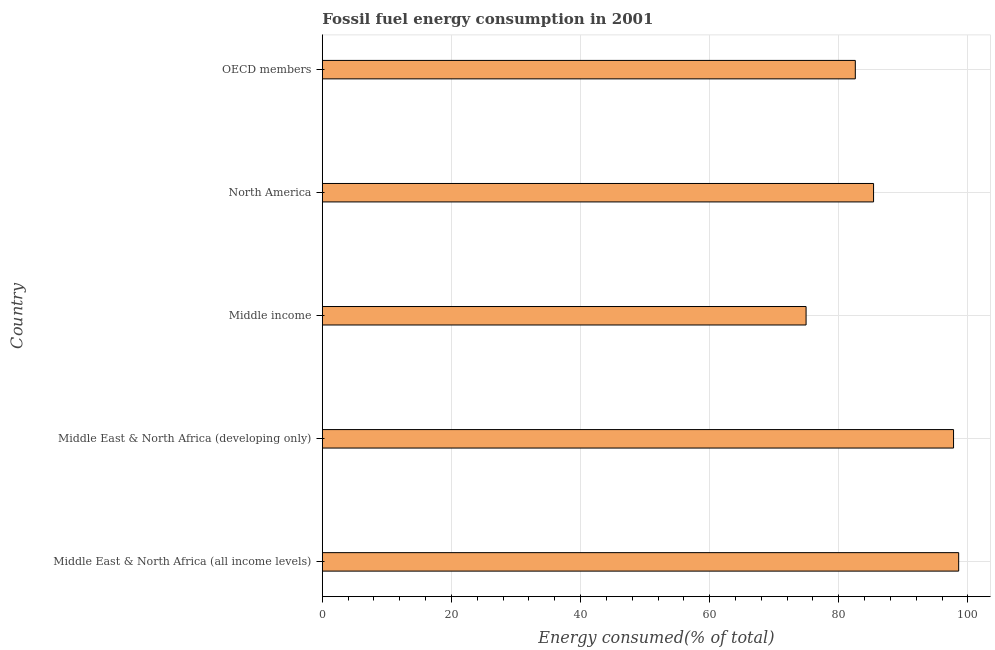Does the graph contain grids?
Give a very brief answer. Yes. What is the title of the graph?
Offer a very short reply. Fossil fuel energy consumption in 2001. What is the label or title of the X-axis?
Keep it short and to the point. Energy consumed(% of total). What is the label or title of the Y-axis?
Your answer should be compact. Country. What is the fossil fuel energy consumption in Middle East & North Africa (developing only)?
Ensure brevity in your answer.  97.78. Across all countries, what is the maximum fossil fuel energy consumption?
Make the answer very short. 98.57. Across all countries, what is the minimum fossil fuel energy consumption?
Make the answer very short. 74.94. In which country was the fossil fuel energy consumption maximum?
Keep it short and to the point. Middle East & North Africa (all income levels). What is the sum of the fossil fuel energy consumption?
Your response must be concise. 439.24. What is the difference between the fossil fuel energy consumption in Middle East & North Africa (developing only) and Middle income?
Give a very brief answer. 22.84. What is the average fossil fuel energy consumption per country?
Offer a very short reply. 87.85. What is the median fossil fuel energy consumption?
Provide a short and direct response. 85.39. What is the ratio of the fossil fuel energy consumption in Middle East & North Africa (all income levels) to that in OECD members?
Your answer should be compact. 1.19. Is the fossil fuel energy consumption in Middle East & North Africa (all income levels) less than that in OECD members?
Ensure brevity in your answer.  No. What is the difference between the highest and the second highest fossil fuel energy consumption?
Give a very brief answer. 0.79. Is the sum of the fossil fuel energy consumption in Middle income and North America greater than the maximum fossil fuel energy consumption across all countries?
Your answer should be compact. Yes. What is the difference between the highest and the lowest fossil fuel energy consumption?
Your answer should be very brief. 23.64. What is the difference between two consecutive major ticks on the X-axis?
Your answer should be compact. 20. Are the values on the major ticks of X-axis written in scientific E-notation?
Ensure brevity in your answer.  No. What is the Energy consumed(% of total) of Middle East & North Africa (all income levels)?
Your response must be concise. 98.57. What is the Energy consumed(% of total) in Middle East & North Africa (developing only)?
Provide a succinct answer. 97.78. What is the Energy consumed(% of total) of Middle income?
Offer a terse response. 74.94. What is the Energy consumed(% of total) of North America?
Ensure brevity in your answer.  85.39. What is the Energy consumed(% of total) of OECD members?
Offer a terse response. 82.56. What is the difference between the Energy consumed(% of total) in Middle East & North Africa (all income levels) and Middle East & North Africa (developing only)?
Ensure brevity in your answer.  0.79. What is the difference between the Energy consumed(% of total) in Middle East & North Africa (all income levels) and Middle income?
Provide a succinct answer. 23.64. What is the difference between the Energy consumed(% of total) in Middle East & North Africa (all income levels) and North America?
Provide a succinct answer. 13.18. What is the difference between the Energy consumed(% of total) in Middle East & North Africa (all income levels) and OECD members?
Keep it short and to the point. 16.01. What is the difference between the Energy consumed(% of total) in Middle East & North Africa (developing only) and Middle income?
Make the answer very short. 22.84. What is the difference between the Energy consumed(% of total) in Middle East & North Africa (developing only) and North America?
Offer a terse response. 12.39. What is the difference between the Energy consumed(% of total) in Middle East & North Africa (developing only) and OECD members?
Give a very brief answer. 15.22. What is the difference between the Energy consumed(% of total) in Middle income and North America?
Your answer should be very brief. -10.45. What is the difference between the Energy consumed(% of total) in Middle income and OECD members?
Give a very brief answer. -7.63. What is the difference between the Energy consumed(% of total) in North America and OECD members?
Offer a terse response. 2.83. What is the ratio of the Energy consumed(% of total) in Middle East & North Africa (all income levels) to that in Middle East & North Africa (developing only)?
Give a very brief answer. 1.01. What is the ratio of the Energy consumed(% of total) in Middle East & North Africa (all income levels) to that in Middle income?
Give a very brief answer. 1.31. What is the ratio of the Energy consumed(% of total) in Middle East & North Africa (all income levels) to that in North America?
Keep it short and to the point. 1.15. What is the ratio of the Energy consumed(% of total) in Middle East & North Africa (all income levels) to that in OECD members?
Your response must be concise. 1.19. What is the ratio of the Energy consumed(% of total) in Middle East & North Africa (developing only) to that in Middle income?
Provide a short and direct response. 1.3. What is the ratio of the Energy consumed(% of total) in Middle East & North Africa (developing only) to that in North America?
Provide a succinct answer. 1.15. What is the ratio of the Energy consumed(% of total) in Middle East & North Africa (developing only) to that in OECD members?
Your response must be concise. 1.18. What is the ratio of the Energy consumed(% of total) in Middle income to that in North America?
Provide a short and direct response. 0.88. What is the ratio of the Energy consumed(% of total) in Middle income to that in OECD members?
Your answer should be compact. 0.91. What is the ratio of the Energy consumed(% of total) in North America to that in OECD members?
Your response must be concise. 1.03. 